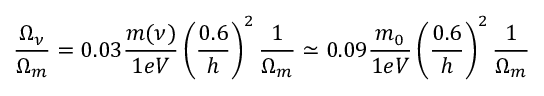<formula> <loc_0><loc_0><loc_500><loc_500>\frac { \Omega _ { \nu } } { \Omega _ { m } } = 0 . 0 3 \frac { m ( \nu ) } { 1 e V } \left ( \frac { 0 . 6 } { h } \right ) ^ { 2 } \frac { 1 } { \Omega _ { m } } \simeq 0 . 0 9 \frac { m _ { 0 } } { 1 e V } \left ( \frac { 0 . 6 } { h } \right ) ^ { 2 } \frac { 1 } { \Omega _ { m } }</formula> 